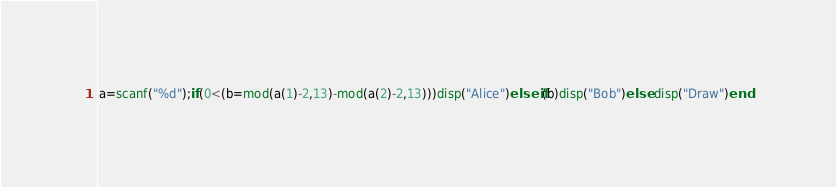<code> <loc_0><loc_0><loc_500><loc_500><_Octave_>a=scanf("%d");if(0<(b=mod(a(1)-2,13)-mod(a(2)-2,13)))disp("Alice")elseif(b)disp("Bob")else disp("Draw")end</code> 